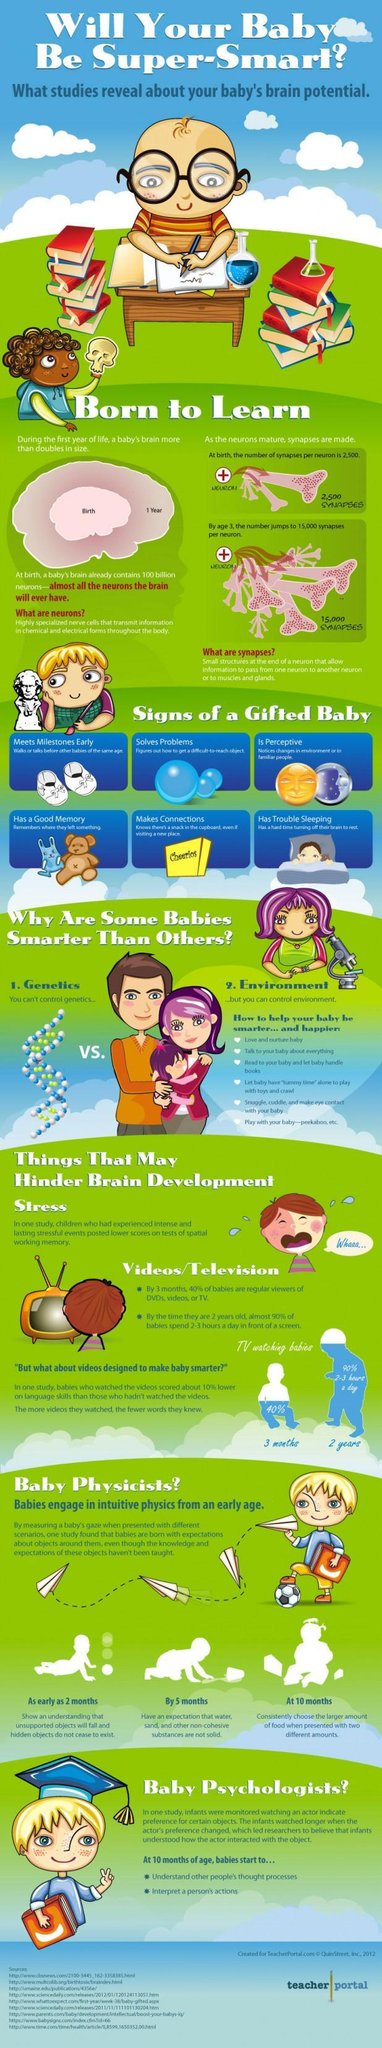How many points are under the heading videos /television?
Answer the question with a short phrase. 2 How many points are there for a gifted baby? 6 At what age, a baby can interpret a person's actions? 10 months 